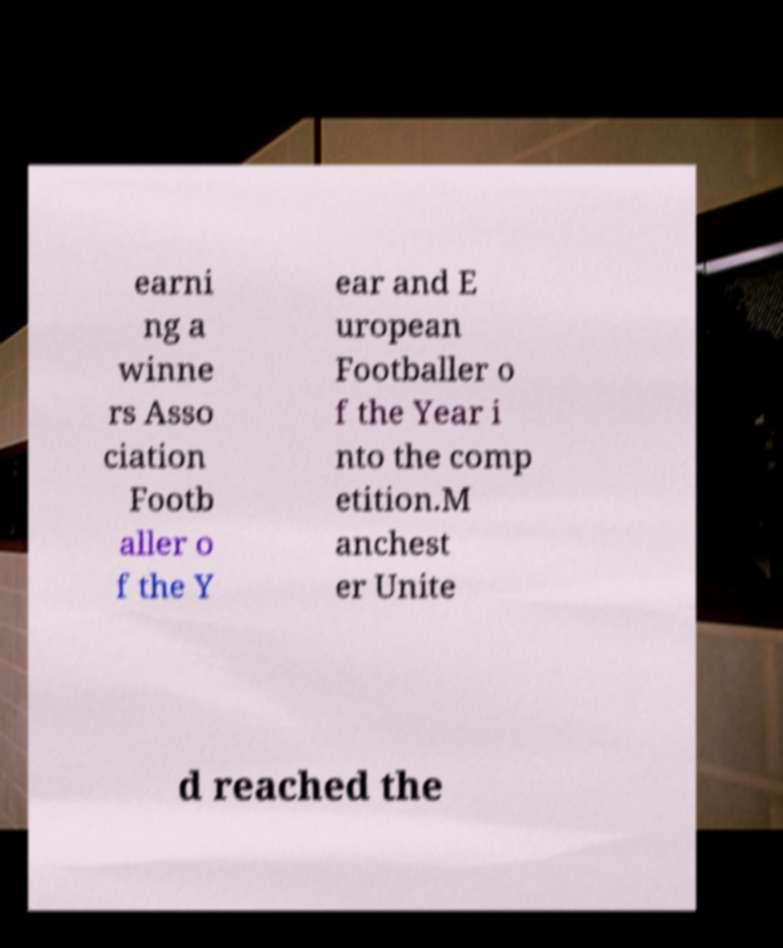I need the written content from this picture converted into text. Can you do that? earni ng a winne rs Asso ciation Footb aller o f the Y ear and E uropean Footballer o f the Year i nto the comp etition.M anchest er Unite d reached the 